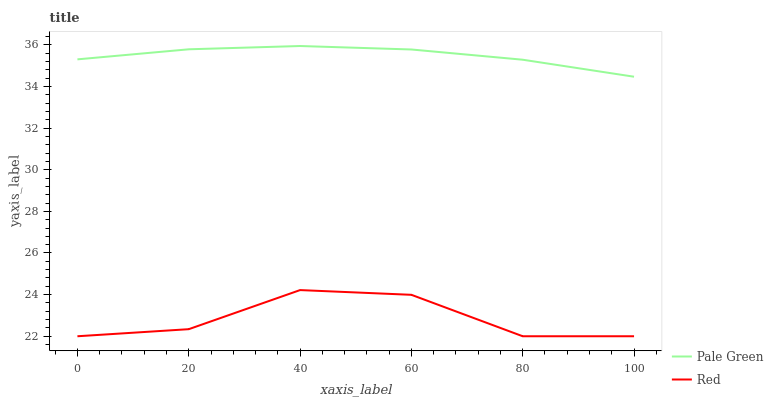Does Red have the minimum area under the curve?
Answer yes or no. Yes. Does Pale Green have the maximum area under the curve?
Answer yes or no. Yes. Does Red have the maximum area under the curve?
Answer yes or no. No. Is Pale Green the smoothest?
Answer yes or no. Yes. Is Red the roughest?
Answer yes or no. Yes. Is Red the smoothest?
Answer yes or no. No. Does Red have the lowest value?
Answer yes or no. Yes. Does Pale Green have the highest value?
Answer yes or no. Yes. Does Red have the highest value?
Answer yes or no. No. Is Red less than Pale Green?
Answer yes or no. Yes. Is Pale Green greater than Red?
Answer yes or no. Yes. Does Red intersect Pale Green?
Answer yes or no. No. 